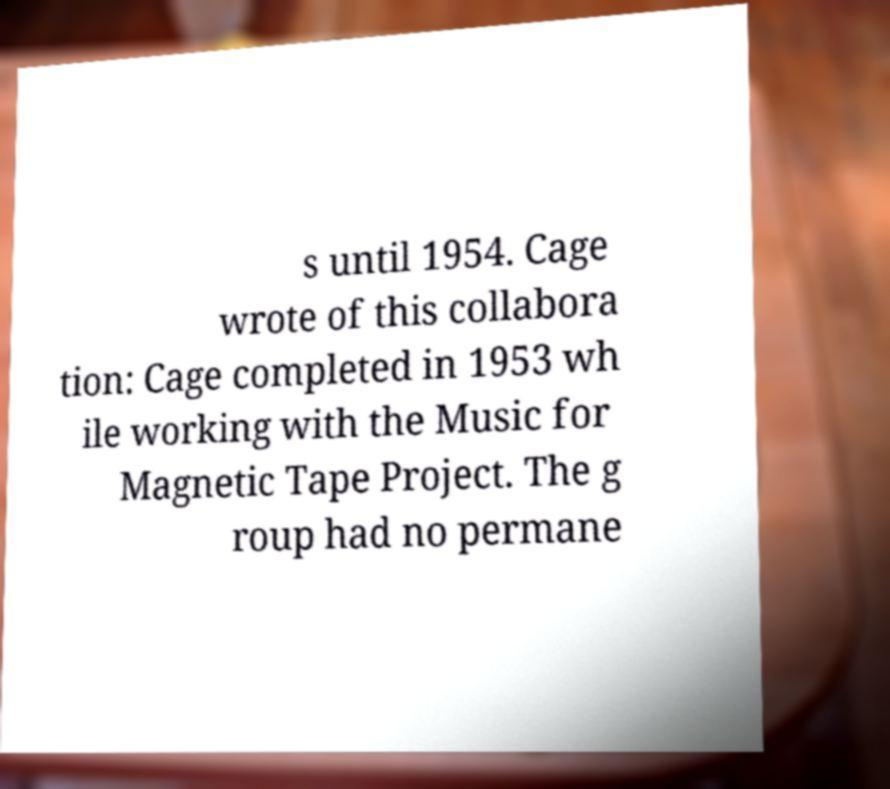What messages or text are displayed in this image? I need them in a readable, typed format. s until 1954. Cage wrote of this collabora tion: Cage completed in 1953 wh ile working with the Music for Magnetic Tape Project. The g roup had no permane 